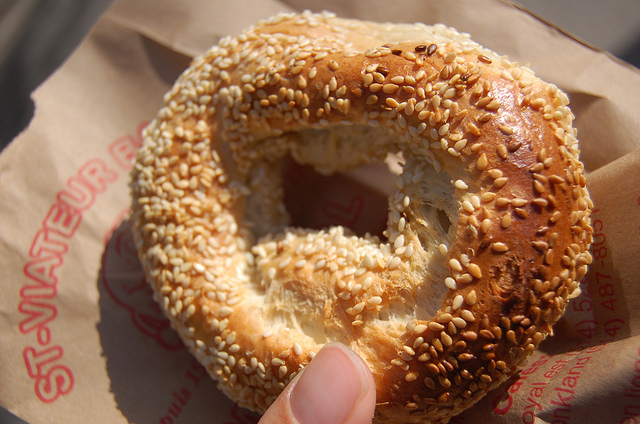Please transcribe the text in this image. -VIATEUR ST 